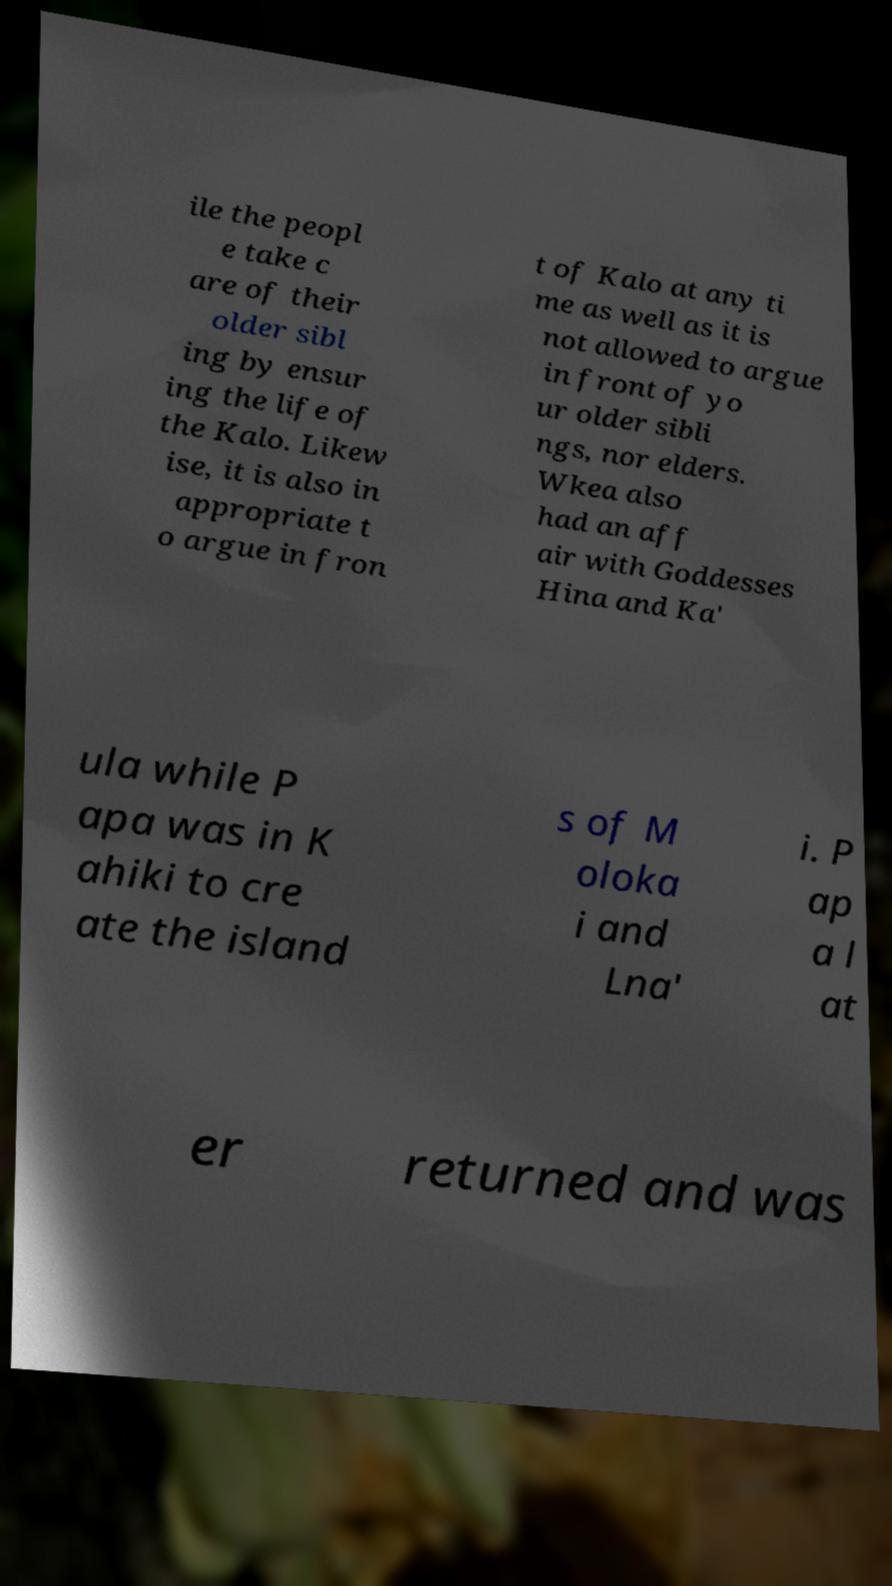Please identify and transcribe the text found in this image. ile the peopl e take c are of their older sibl ing by ensur ing the life of the Kalo. Likew ise, it is also in appropriate t o argue in fron t of Kalo at any ti me as well as it is not allowed to argue in front of yo ur older sibli ngs, nor elders. Wkea also had an aff air with Goddesses Hina and Ka' ula while P apa was in K ahiki to cre ate the island s of M oloka i and Lna' i. P ap a l at er returned and was 